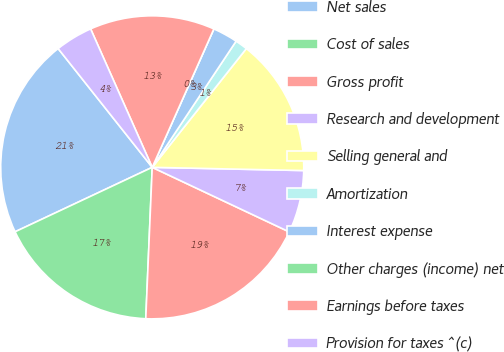Convert chart. <chart><loc_0><loc_0><loc_500><loc_500><pie_chart><fcel>Net sales<fcel>Cost of sales<fcel>Gross profit<fcel>Research and development<fcel>Selling general and<fcel>Amortization<fcel>Interest expense<fcel>Other charges (income) net<fcel>Earnings before taxes<fcel>Provision for taxes ^(c)<nl><fcel>21.33%<fcel>17.33%<fcel>18.67%<fcel>6.67%<fcel>14.67%<fcel>1.33%<fcel>2.67%<fcel>0.0%<fcel>13.33%<fcel>4.0%<nl></chart> 